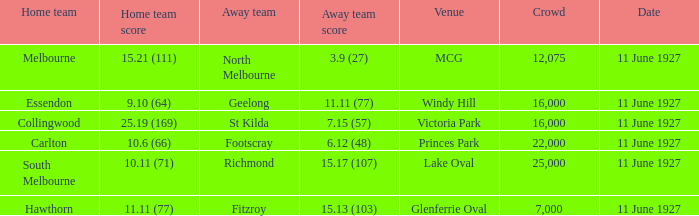How many people were in the crowd when Essendon was the home team? 1.0. 